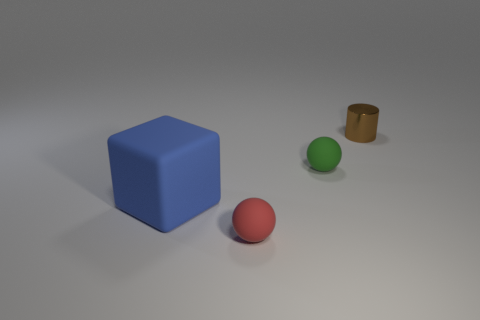Do the thing that is in front of the blue matte block and the matte object that is on the left side of the tiny red ball have the same size?
Ensure brevity in your answer.  No. Is there any other thing that is the same material as the cylinder?
Offer a very short reply. No. How many brown things are metal objects or tiny objects?
Your response must be concise. 1. What is the color of the rubber object that is behind the tiny red thing and to the right of the big block?
Ensure brevity in your answer.  Green. How many tiny objects are balls or red things?
Your response must be concise. 2. What size is the red thing that is the same shape as the small green matte object?
Provide a short and direct response. Small. The blue object has what shape?
Your answer should be compact. Cube. Do the green ball and the sphere that is on the left side of the green object have the same material?
Make the answer very short. Yes. What number of metal things are big blue cubes or small green things?
Provide a short and direct response. 0. There is a matte object on the left side of the small red matte ball; what is its size?
Your response must be concise. Large. 